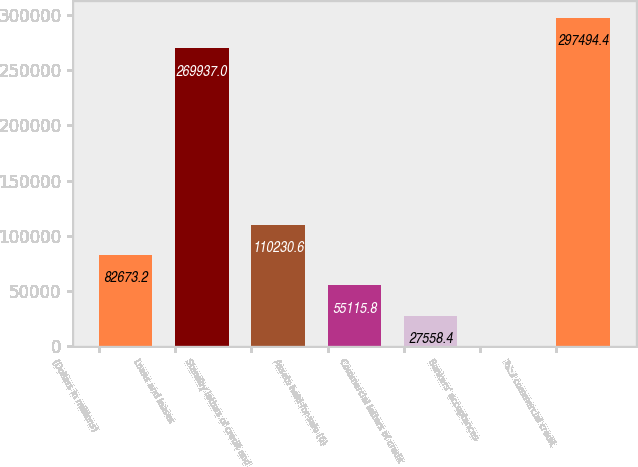<chart> <loc_0><loc_0><loc_500><loc_500><bar_chart><fcel>(Dollars in millions)<fcel>Loans and leases<fcel>Standby letters of credit and<fcel>Assets held-for-sale (6)<fcel>Commercial letters of credit<fcel>Bankers' acceptances<fcel>Total commercial credit<nl><fcel>82673.2<fcel>269937<fcel>110231<fcel>55115.8<fcel>27558.4<fcel>1<fcel>297494<nl></chart> 